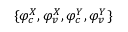Convert formula to latex. <formula><loc_0><loc_0><loc_500><loc_500>\{ \varphi _ { c } ^ { X } , \varphi _ { v } ^ { X } , \varphi _ { c } ^ { Y } , \varphi _ { v } ^ { Y } \}</formula> 